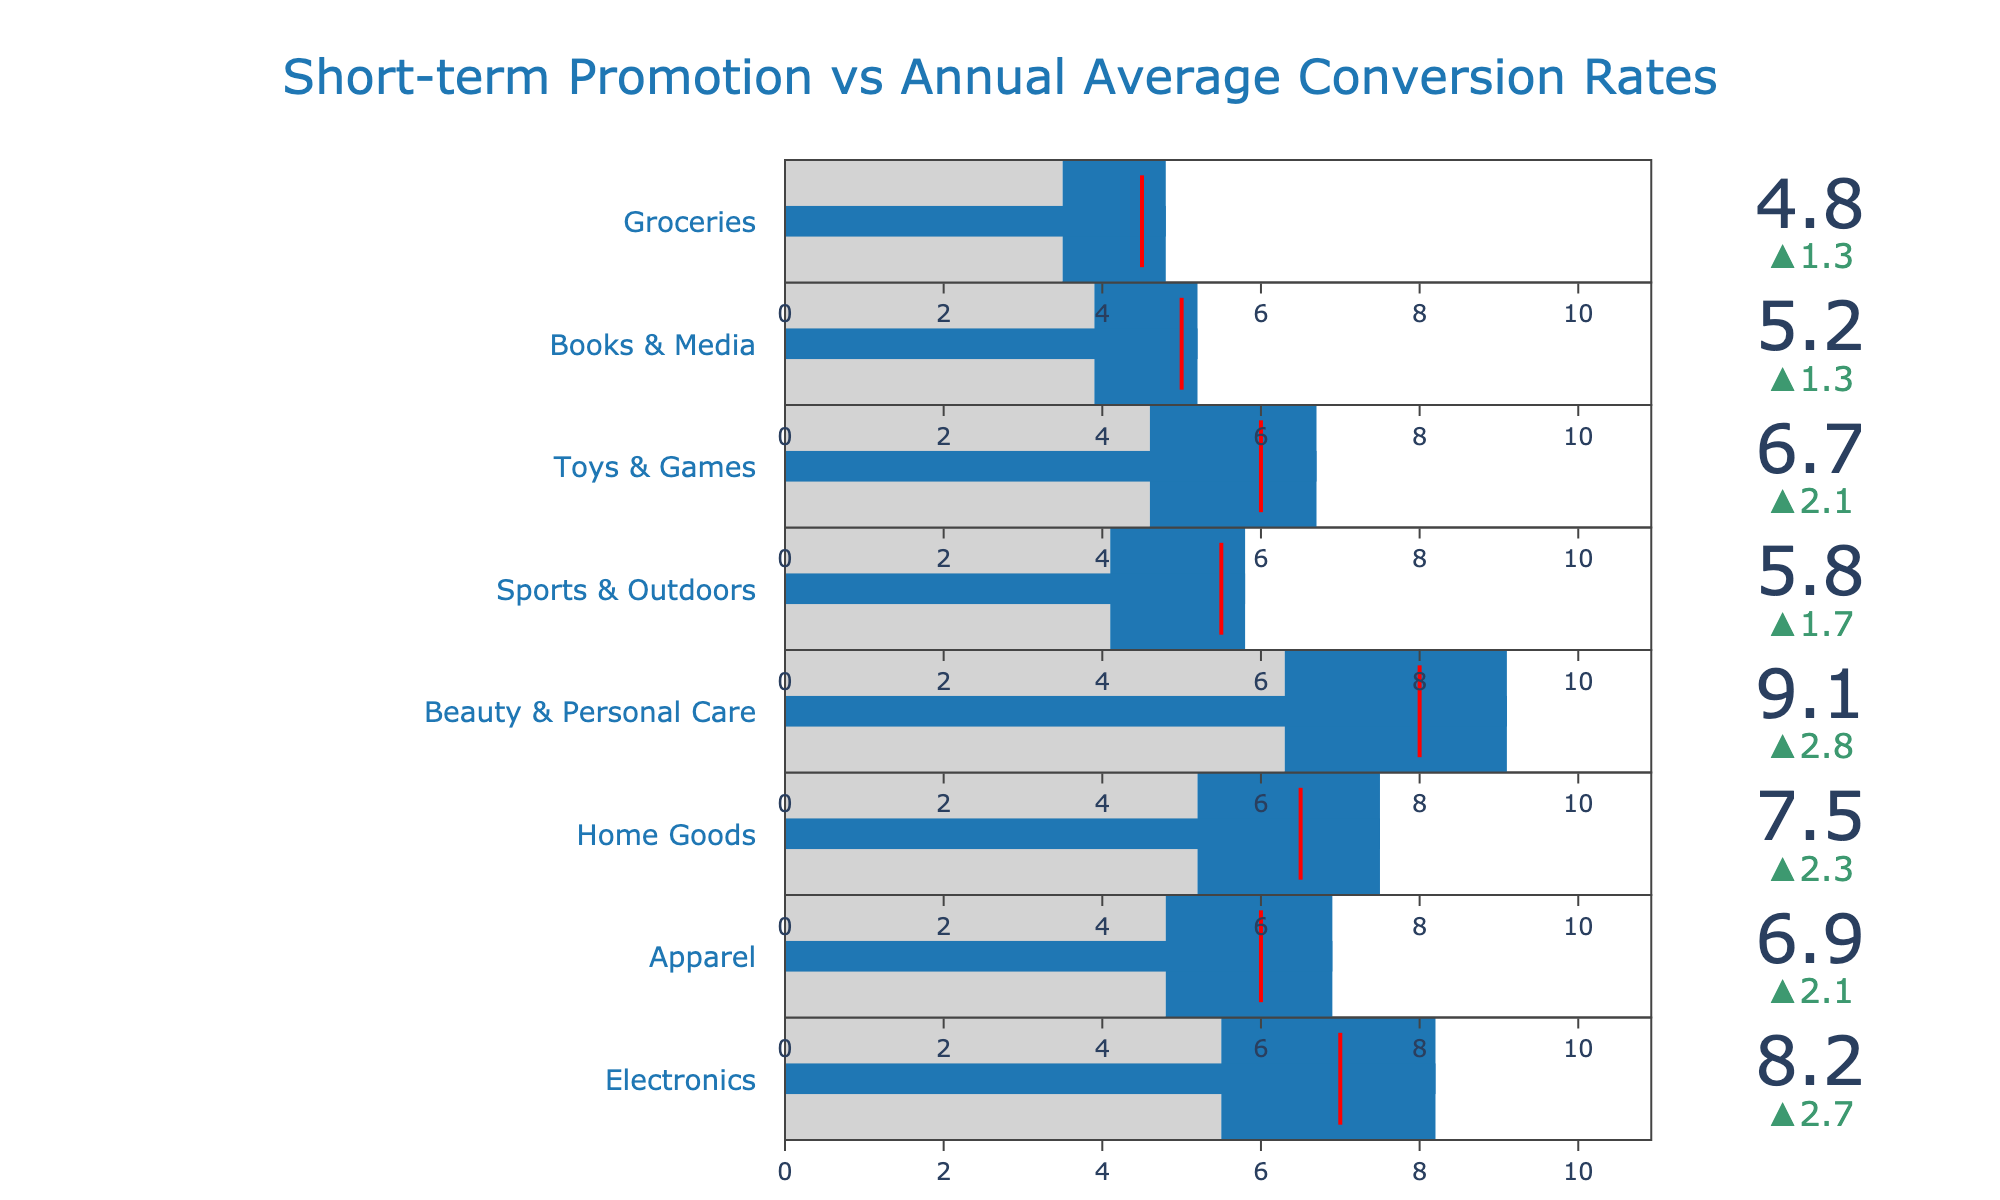What's the title of the figure? The title of the figure is generally found at the top of the chart and serves to describe the main focus of the visualization.
Answer: Short-term Promotion vs Annual Average Conversion Rates How many product lines are represented in the figure? Count the number of rows or entries in the bullet chart, each representing a different product line.
Answer: 8 Which product line has the highest short-term promotion conversion rate? Look for the product line with the longest blue bar, indicating the highest short-term promotion conversion rate.
Answer: Beauty & Personal Care What is the target conversion rate for Electronics, and did the short-term promotion exceed it? Locate the red threshold line for Electronics to identify the target conversion rate, then see if the short-term promotion bar extends past this line.
Answer: Target is 7.0; Yes, it exceeded it How does the conversion rate for Apparel compare to its annual average? Examine the blue bar (short-term promotion) and the gray bar (annual average) for Apparel to compare their lengths.
Answer: Higher than the annual average Is there any product line where the annual average conversion rate is higher than the short-term promotion conversion rate? Compare each product line's blue and gray bars to see if the gray bar exceeds the blue bar in any case.
Answer: No What is the delta (difference) between the short-term promotion conversion rate and the annual average for Toys & Games? Find the difference between the two rates for Toys & Games by subtracting the annual average from the short-term promotion rate.
Answer: 2.1 (6.7 - 4.6) For which product lines did the short-term promotion conversion rate not meet the target? Identify product lines where the blue bar does not reach the red threshold line.
Answer: None Which product line had the smallest increase in conversion rate due to short-term promotions? Calculate the difference between the short-term promotion rate and the annual average for each product line and find the smallest value.
Answer: Groceries How much higher is the conversion rate for Beauty & Personal Care during short-term promotions compared to its annual average? Subtract the annual average conversion rate from the short-term promotion conversion rate for Beauty & Personal Care.
Answer: 2.8 (9.1 - 6.3) 